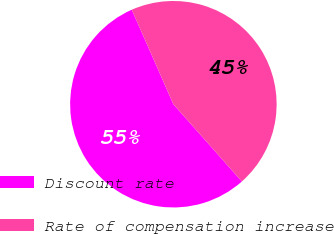Convert chart. <chart><loc_0><loc_0><loc_500><loc_500><pie_chart><fcel>Discount rate<fcel>Rate of compensation increase<nl><fcel>54.94%<fcel>45.06%<nl></chart> 